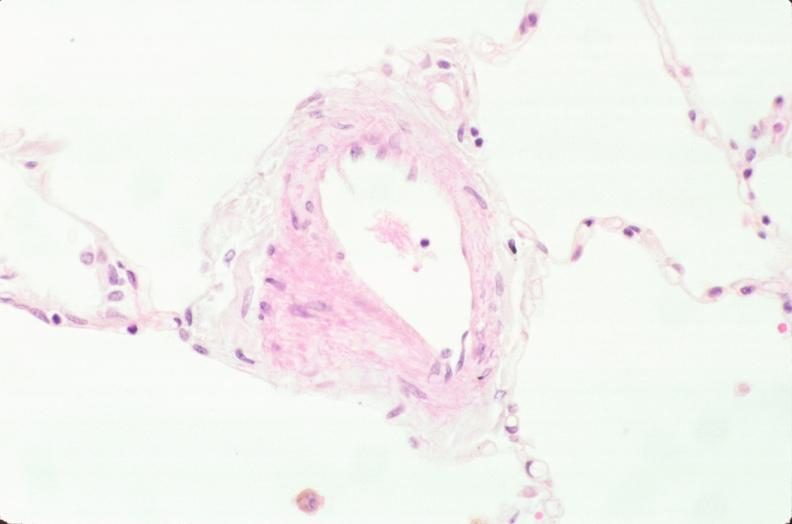where is this?
Answer the question using a single word or phrase. Lung 